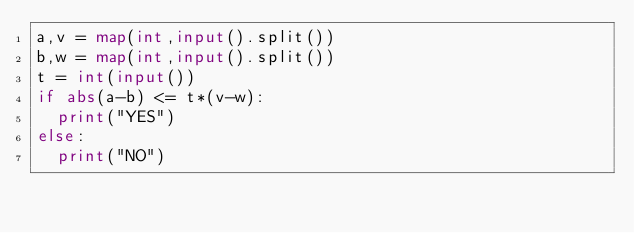Convert code to text. <code><loc_0><loc_0><loc_500><loc_500><_Python_>a,v = map(int,input().split())
b,w = map(int,input().split())
t = int(input())
if abs(a-b) <= t*(v-w):
  print("YES")
else:
  print("NO")</code> 